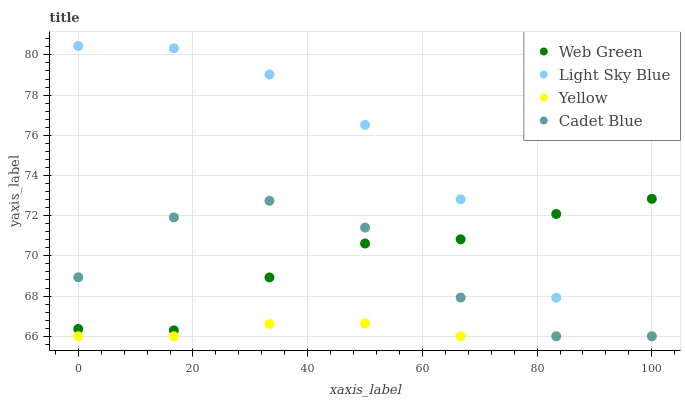Does Yellow have the minimum area under the curve?
Answer yes or no. Yes. Does Light Sky Blue have the maximum area under the curve?
Answer yes or no. Yes. Does Light Sky Blue have the minimum area under the curve?
Answer yes or no. No. Does Yellow have the maximum area under the curve?
Answer yes or no. No. Is Yellow the smoothest?
Answer yes or no. Yes. Is Cadet Blue the roughest?
Answer yes or no. Yes. Is Light Sky Blue the smoothest?
Answer yes or no. No. Is Light Sky Blue the roughest?
Answer yes or no. No. Does Cadet Blue have the lowest value?
Answer yes or no. Yes. Does Web Green have the lowest value?
Answer yes or no. No. Does Light Sky Blue have the highest value?
Answer yes or no. Yes. Does Yellow have the highest value?
Answer yes or no. No. Is Yellow less than Web Green?
Answer yes or no. Yes. Is Web Green greater than Yellow?
Answer yes or no. Yes. Does Web Green intersect Light Sky Blue?
Answer yes or no. Yes. Is Web Green less than Light Sky Blue?
Answer yes or no. No. Is Web Green greater than Light Sky Blue?
Answer yes or no. No. Does Yellow intersect Web Green?
Answer yes or no. No. 